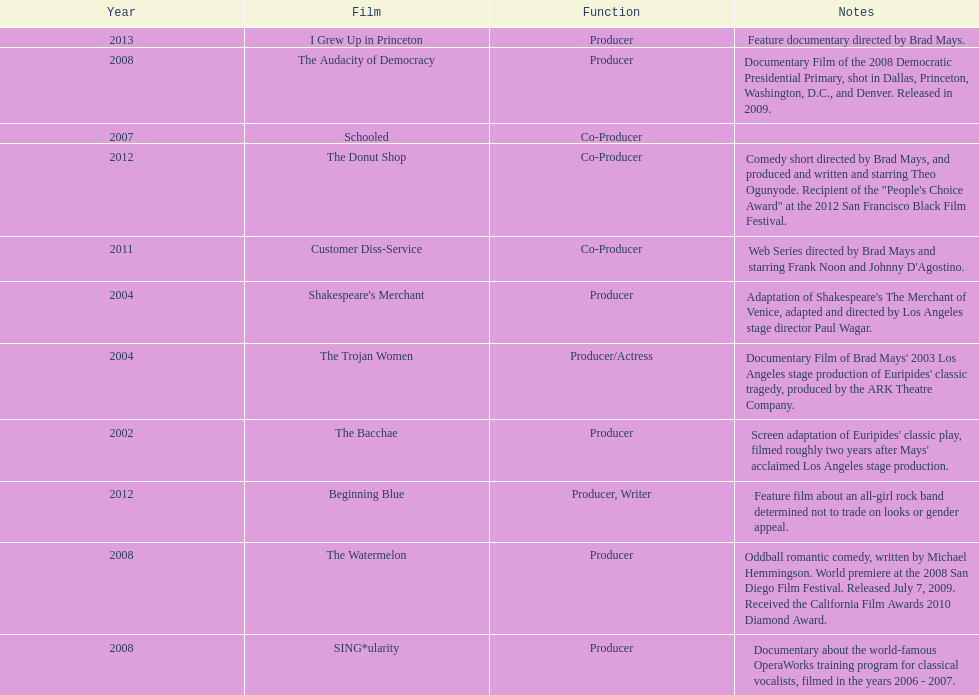How many films did ms. starfelt produce after 2010? 4. 